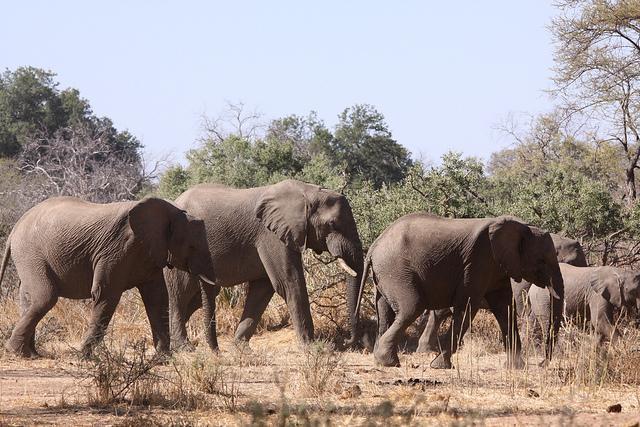How many total elephants are visible?
Give a very brief answer. 5. How many elephants are there?
Give a very brief answer. 4. How many oranges can be seen in the bottom box?
Give a very brief answer. 0. 